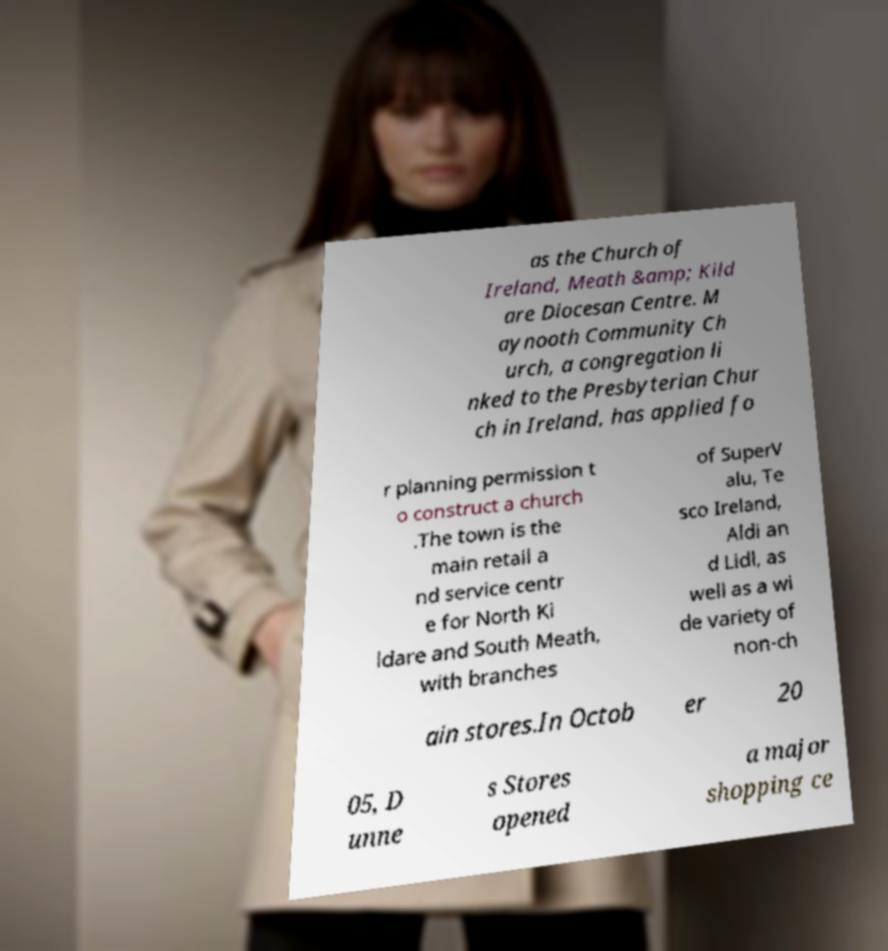There's text embedded in this image that I need extracted. Can you transcribe it verbatim? as the Church of Ireland, Meath &amp; Kild are Diocesan Centre. M aynooth Community Ch urch, a congregation li nked to the Presbyterian Chur ch in Ireland, has applied fo r planning permission t o construct a church .The town is the main retail a nd service centr e for North Ki ldare and South Meath, with branches of SuperV alu, Te sco Ireland, Aldi an d Lidl, as well as a wi de variety of non-ch ain stores.In Octob er 20 05, D unne s Stores opened a major shopping ce 